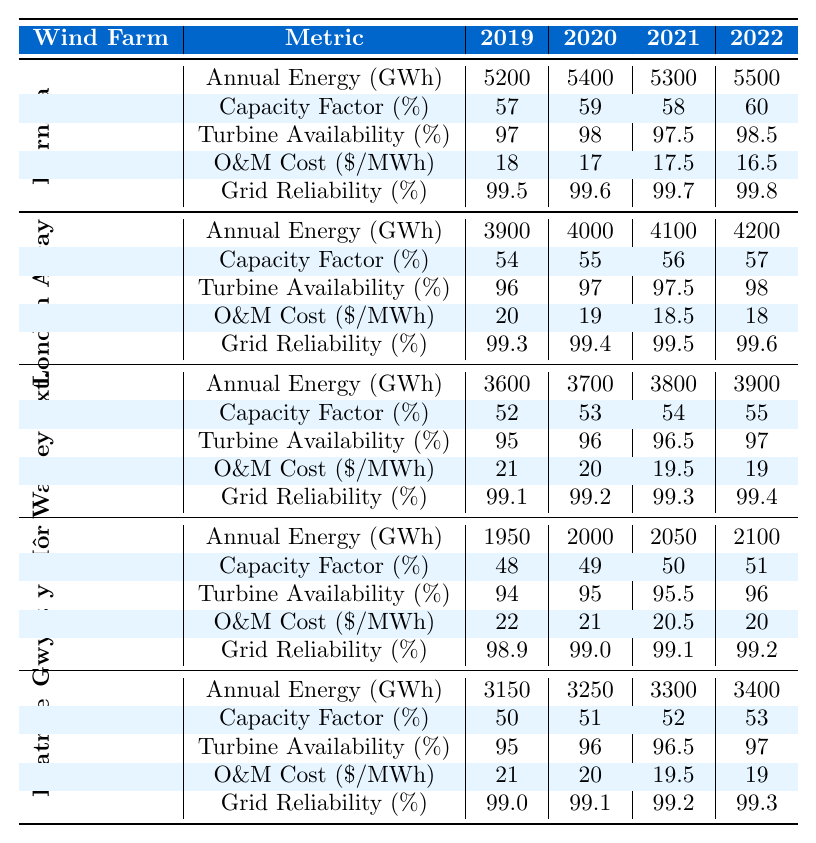What is the Annual Energy Production for the Hornsea Wind Farm in 2022? According to the table, the Annual Energy Production for Hornsea in 2022 is listed as 5500 GWh.
Answer: 5500 GWh Which wind farm had the highest capacity factor in 2021? The table shows that Hornsea had a capacity factor of 58% in 2021, which is higher than the other wind farms: London Array (56%), Walney Extension (54%), Gwynt y Môr (50%), and Beatrice (52%).
Answer: Hornsea Wind Farm What was the average O&M cost per MWh across all wind farms in 2020? The O&M costs for 2020 are: Hornsea (17), London Array (19), Walney Extension (20), Gwynt y Môr (21), and Beatrice (20). The sum is 97 and dividing by 5 gives an average of 19.4.
Answer: 19.4 Did Gwynt y Môr’s turbine availability increase every year from 2019 to 2022? The turbine availability for Gwynt y Môr was 94% in 2019, 95% in 2020, 95.5% in 2021, and 96% in 2022, indicating an increase every year.
Answer: Yes What is the difference in grid reliability between the Hornsea and the Beatrice wind farms in 2022? The grid reliability for Hornsea in 2022 is 99.8% and for Beatrice, it is 99.3%. The difference is 99.8 - 99.3 = 0.5%.
Answer: 0.5% Which wind farm had the lowest Annual Energy Production in 2019? The table shows that Gwynt y Môr had the lowest Annual Energy Production in 2019, with 1950 GWh, compared to the other farms.
Answer: Gwynt y Môr What was the trend of the O&M costs for Hornsea from 2019 to 2022? The O&M costs for Hornsea were 18 in 2019, dropped to 17 in 2020, rose again to 17.5 in 2021, and then decreased to 16.5 in 2022. This indicates a general downward trend overall.
Answer: Downward trend What is the highest recorded capacity factor among the listed wind farms and in which year was it observed? Reviewing the table, the highest capacity factor is 60% for Hornsea in the year 2022, higher than all other values seen across the wind farms.
Answer: 60% in 2022 Is the capacity factor for Walney Extension higher than that of Gwynt y Môr in 2020? In 2020, Walney Extension has a capacity factor of 53%, while Gwynt y Môr has 49%. Thus, Walney Extension's capacity factor is indeed higher.
Answer: Yes What was the total Annual Energy Production of all wind farms combined in 2021? The total production for 2021 is: Hornsea (5300) + London Array (4100) + Walney Extension (3800) + Gwynt y Môr (2050) + Beatrice (3300). Adding these gives a total of 18550 GWh.
Answer: 18550 GWh 